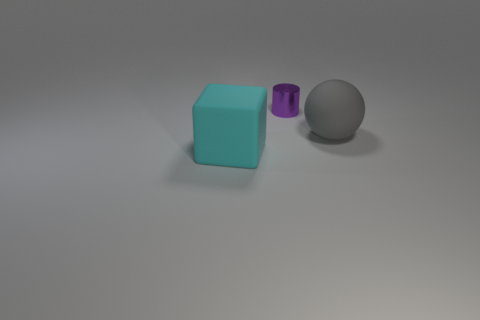What is the lighting like in this image? The lighting in this image appears soft and diffused, with a directional light source coming from above. There are subtle shadows cast by the objects, indicating the light is not directly overhead but angled, which helps to create a gentle contrast and depth in the arrangement of the objects. Does the lighting indicate a specific time of day or setting? The lighting doesn't necessarily indicate a specific time of day, as it's more suggestive of a controlled, indoor environment where lights can be positioned as needed. The lack of harsh shadows and the softness of light could imply a studio setting with professional lighting gear used to create an even and flattering light on the objects. 